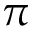Convert formula to latex. <formula><loc_0><loc_0><loc_500><loc_500>\pi</formula> 